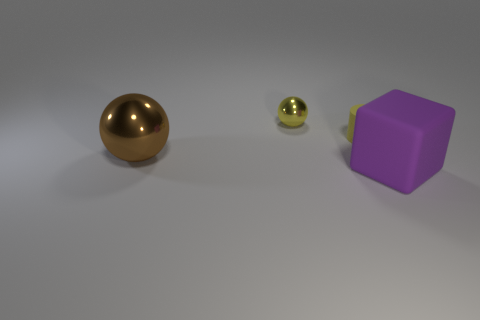What color is the metal thing behind the matte object that is left of the purple matte cube?
Offer a terse response. Yellow. What number of objects are tiny gray rubber cylinders or shiny spheres behind the large brown sphere?
Give a very brief answer. 1. Is there another thing that has the same color as the tiny matte thing?
Give a very brief answer. Yes. What number of yellow things are either big metallic cubes or small metal objects?
Give a very brief answer. 1. What number of other things are there of the same size as the yellow metal object?
Your answer should be very brief. 1. How many small things are either brown spheres or purple cubes?
Offer a very short reply. 0. There is a purple matte object; is it the same size as the metallic thing that is behind the yellow rubber cylinder?
Provide a short and direct response. No. What number of other objects are the same shape as the yellow rubber thing?
Ensure brevity in your answer.  0. The other thing that is the same material as the big brown thing is what shape?
Ensure brevity in your answer.  Sphere. Are any blue rubber blocks visible?
Your answer should be compact. No. 